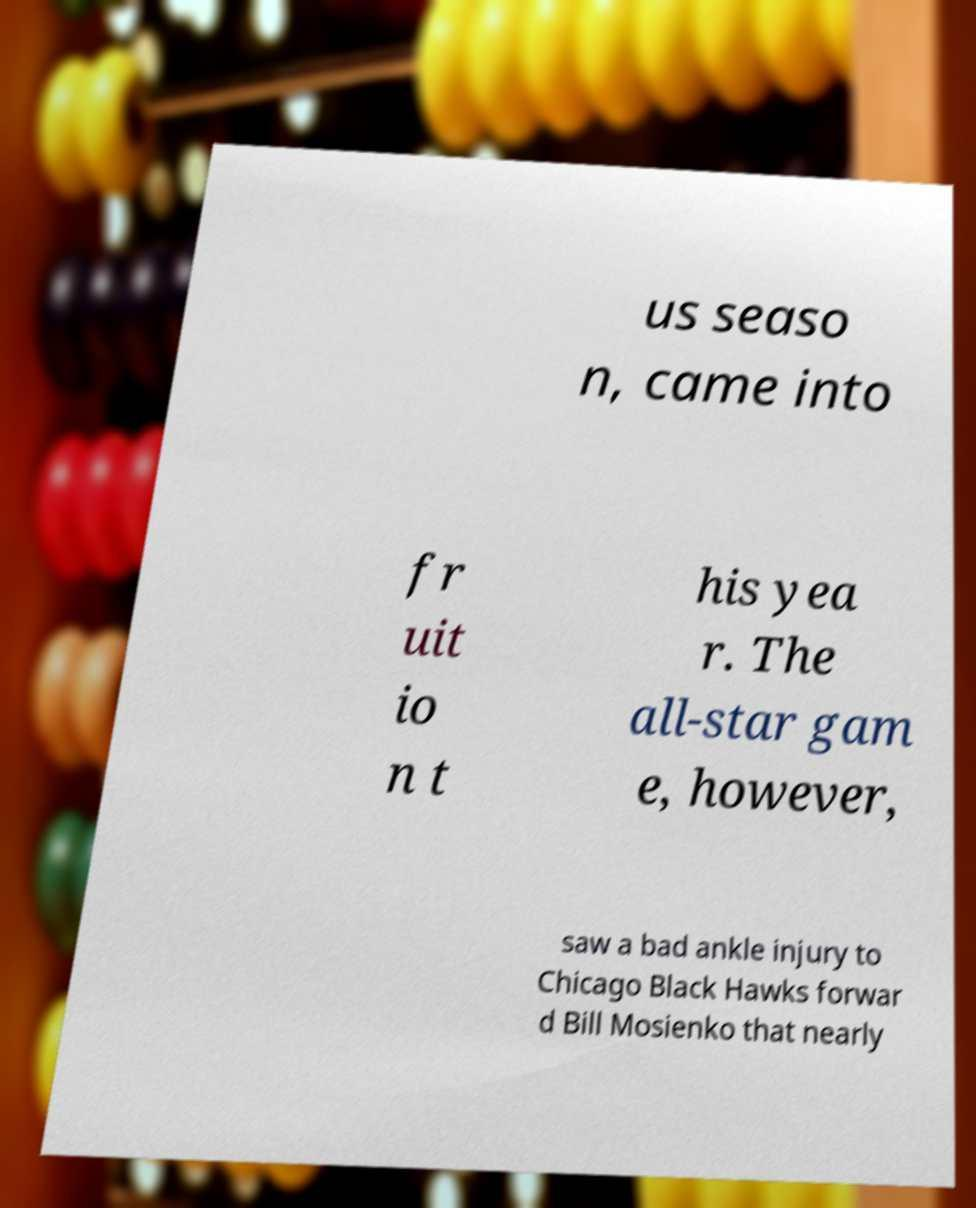There's text embedded in this image that I need extracted. Can you transcribe it verbatim? us seaso n, came into fr uit io n t his yea r. The all-star gam e, however, saw a bad ankle injury to Chicago Black Hawks forwar d Bill Mosienko that nearly 